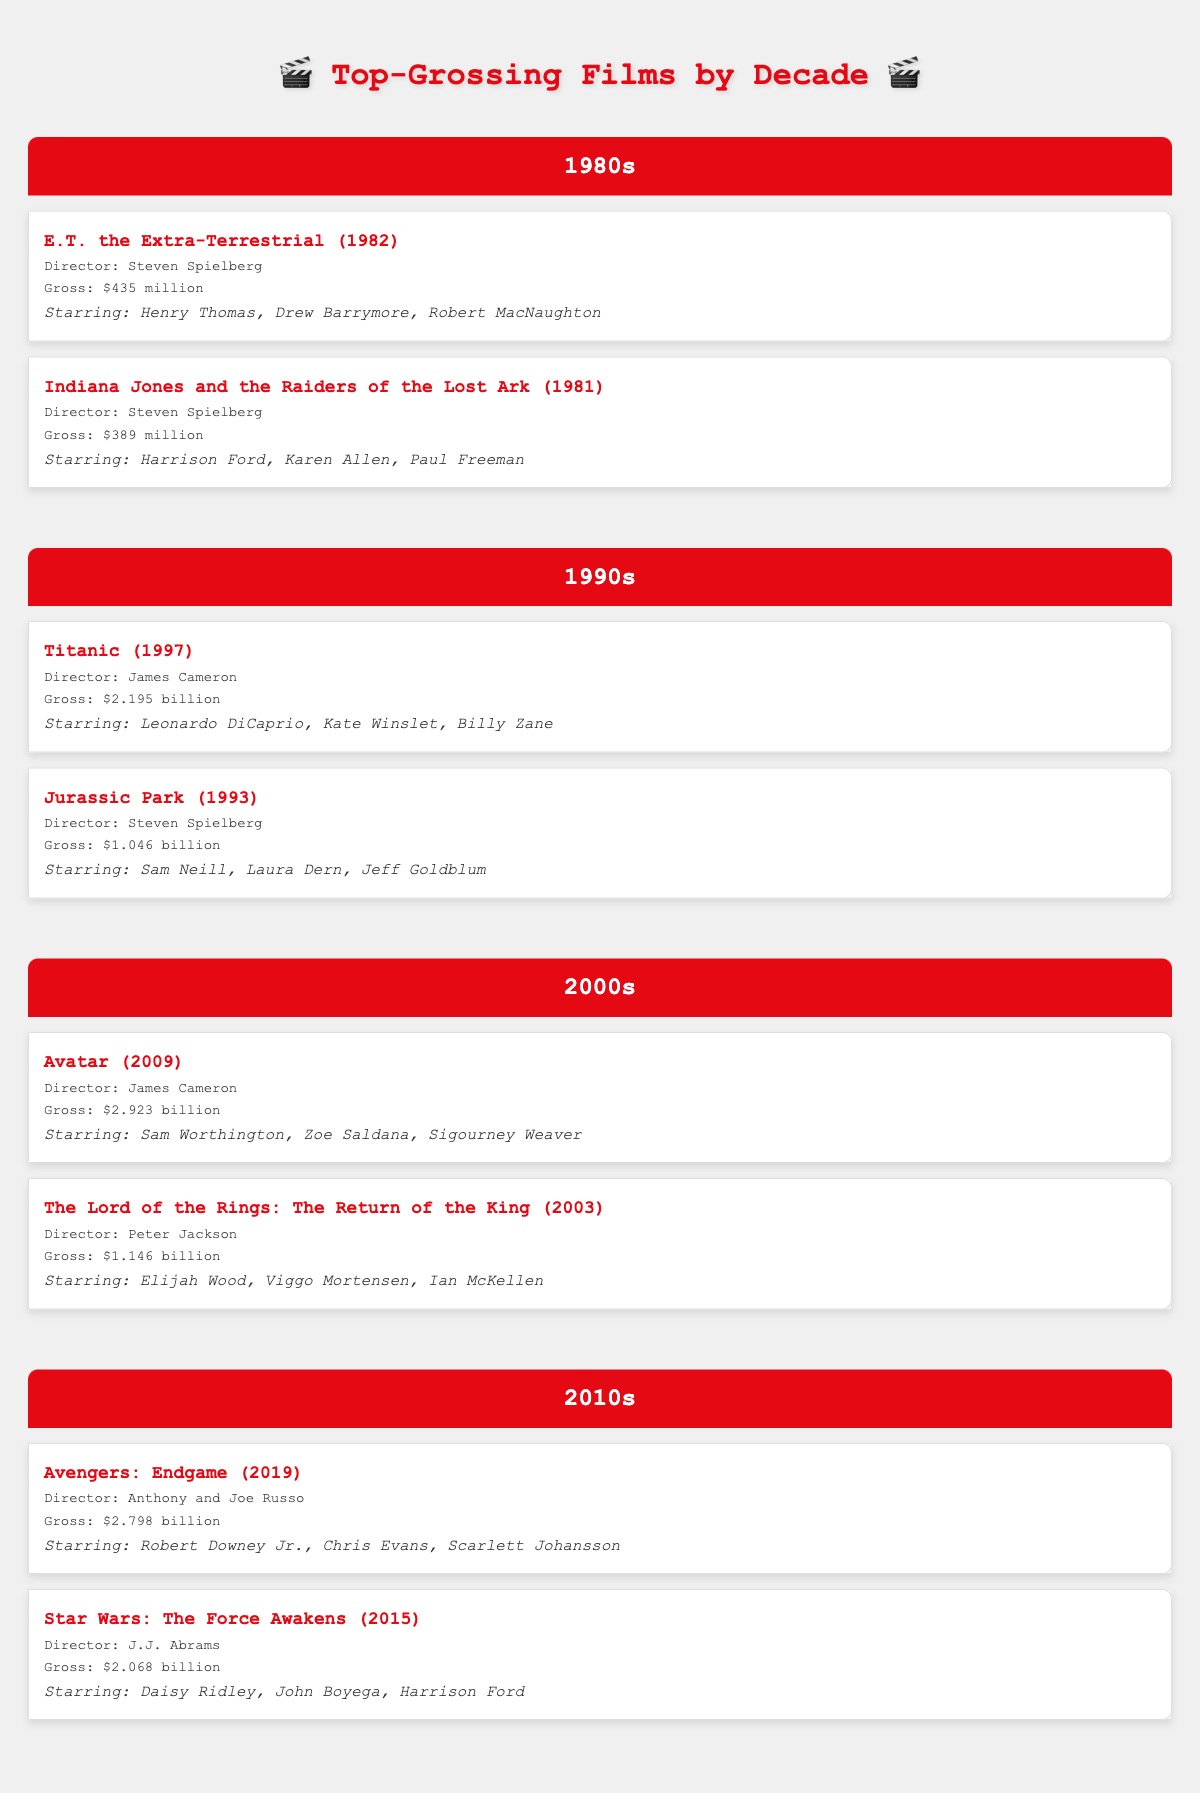What is the highest-grossing film of the 1990s? The table shows two films from the 1990s. 'Titanic' has a gross of $2.195 billion, while 'Jurassic Park' grossed $1.046 billion. Therefore, 'Titanic' is the highest-grossing film of the 1990s.
Answer: Titanic How much did 'Avatar' gross? According to the table, 'Avatar' grossed $2.923 billion.
Answer: $2.923 billion True or False: 'Indiana Jones and the Raiders of the Lost Ark' was directed by James Cameron. The table lists 'Indiana Jones and the Raiders of the Lost Ark' and indicates that it was directed by Steven Spielberg, not James Cameron. Therefore, the statement is false.
Answer: False Which actor starred in both 'Star Wars: The Force Awakens' and 'Indiana Jones and the Raiders of the Lost Ark'? From the table, 'Star Wars: The Force Awakens' features Harrison Ford, and so does 'Indiana Jones and the Raiders of the Lost Ark'. Thus, Harrison Ford is the common actor between both films.
Answer: Harrison Ford What is the total gross of all the films in the 2010s? The table displays two films from the 2010s: 'Avengers: Endgame' with $2.798 billion and 'Star Wars: The Force Awakens' with $2.068 billion. Adding these together gives a total gross of $2.798 billion + $2.068 billion = $4.866 billion.
Answer: $4.866 billion Name one film from the 1980s that grossed more than $400 million. The table indicates that 'E.T. the Extra-Terrestrial' grossed $435 million, which is more than $400 million.
Answer: E.T. the Extra-Terrestrial Which decade had the film with the highest gross? The highest-grossing film from the table is 'Avatar' from the 2000s, which made $2.923 billion. Therefore, the 2000s had the film with the highest gross.
Answer: 2000s Is 'Kate Winslet' an actor in any of the films from the 1980s? The table does not list 'Kate Winslet' as a star in any of the films from the 1980s. The films from that decade feature actors like Henry Thomas and Harrison Ford. Therefore, the statement is false.
Answer: False 